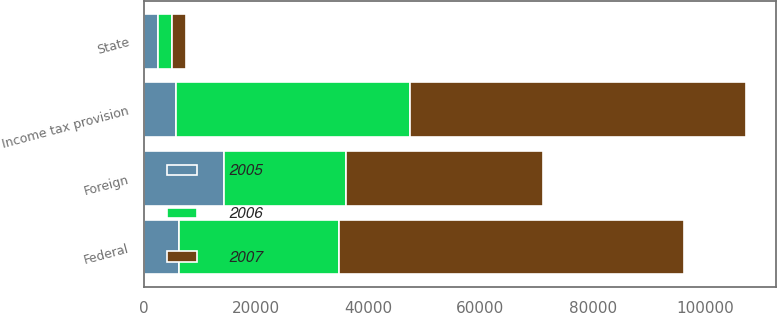Convert chart. <chart><loc_0><loc_0><loc_500><loc_500><stacked_bar_chart><ecel><fcel>State<fcel>Foreign<fcel>Federal<fcel>Income tax provision<nl><fcel>2007<fcel>2531<fcel>35127<fcel>61513<fcel>59809<nl><fcel>2006<fcel>2517<fcel>21716<fcel>28488<fcel>41768<nl><fcel>2005<fcel>2477<fcel>14278<fcel>6230<fcel>5714<nl></chart> 